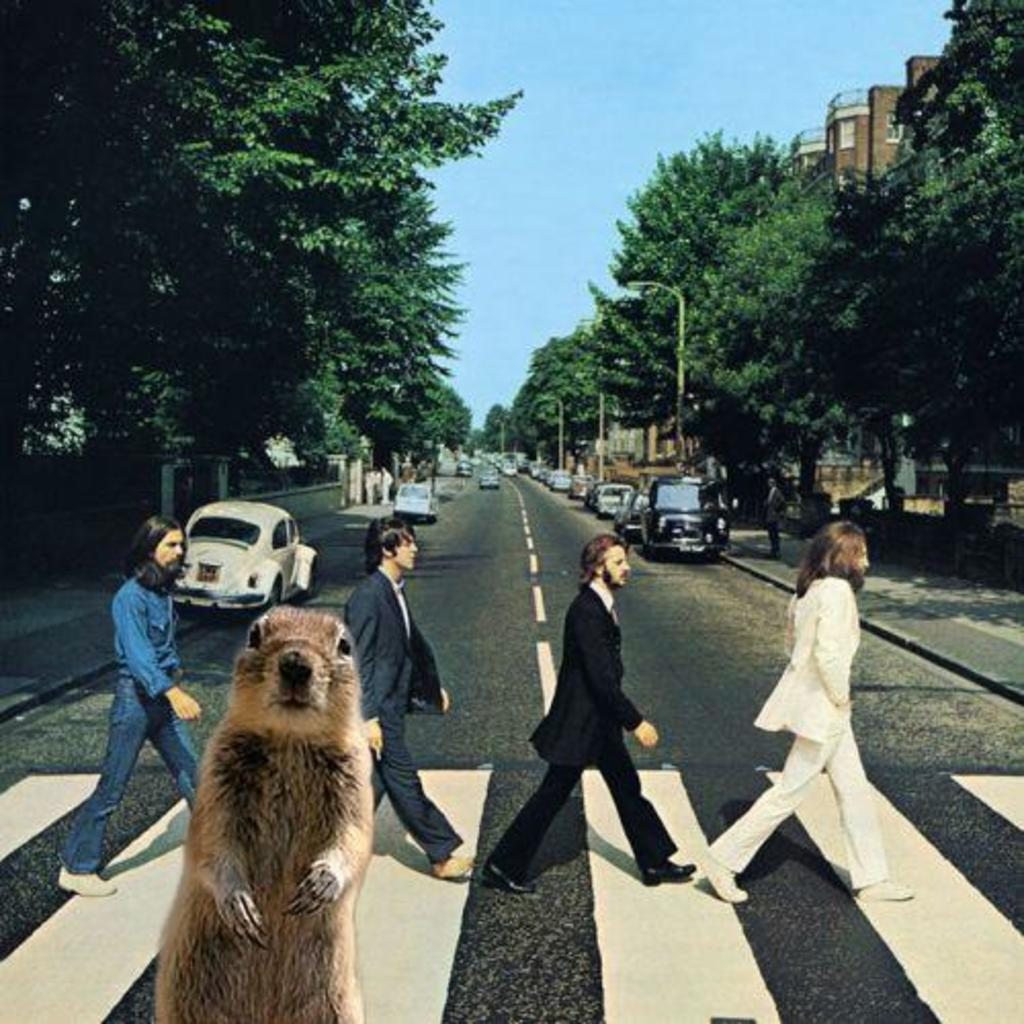What types of objects can be seen in the image? There are vehicles, trees, street lights, and a building in the image. What can be seen in the sky in the image? The sky is visible in the image. What markings are present on the road in the image? There are white lines on the road in the image. Are there any people present in the image? Yes, there are people standing in the image. What type of bone can be seen in the image? There is no bone present in the image. Is there a cellar visible in the image? There is no mention of a cellar in the provided facts, and therefore it cannot be determined if one is present in the image. 